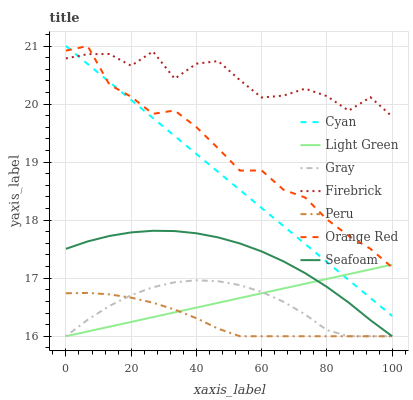Does Peru have the minimum area under the curve?
Answer yes or no. Yes. Does Firebrick have the maximum area under the curve?
Answer yes or no. Yes. Does Light Green have the minimum area under the curve?
Answer yes or no. No. Does Light Green have the maximum area under the curve?
Answer yes or no. No. Is Light Green the smoothest?
Answer yes or no. Yes. Is Firebrick the roughest?
Answer yes or no. Yes. Is Firebrick the smoothest?
Answer yes or no. No. Is Light Green the roughest?
Answer yes or no. No. Does Gray have the lowest value?
Answer yes or no. Yes. Does Firebrick have the lowest value?
Answer yes or no. No. Does Orange Red have the highest value?
Answer yes or no. Yes. Does Light Green have the highest value?
Answer yes or no. No. Is Peru less than Orange Red?
Answer yes or no. Yes. Is Firebrick greater than Light Green?
Answer yes or no. Yes. Does Peru intersect Light Green?
Answer yes or no. Yes. Is Peru less than Light Green?
Answer yes or no. No. Is Peru greater than Light Green?
Answer yes or no. No. Does Peru intersect Orange Red?
Answer yes or no. No. 